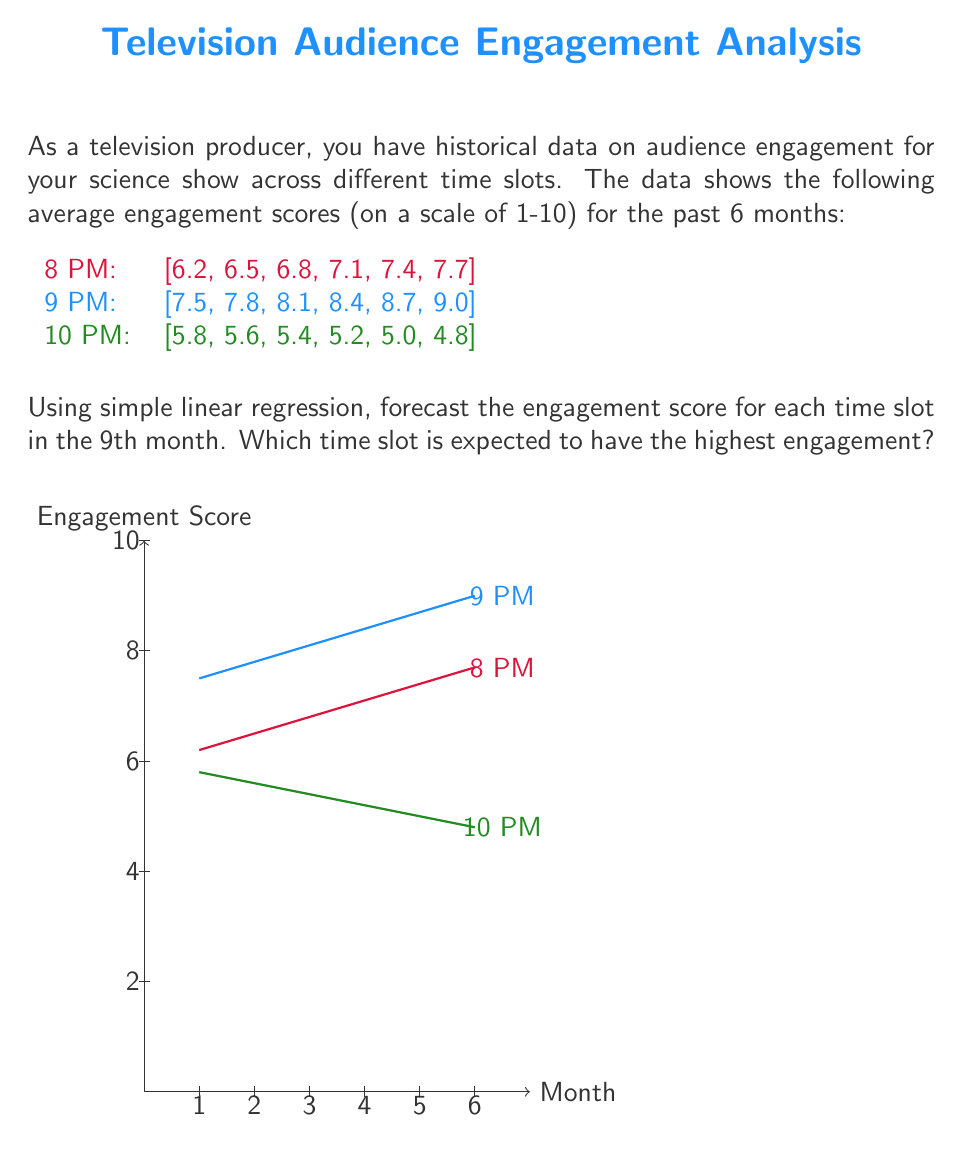Provide a solution to this math problem. To solve this problem, we'll use simple linear regression for each time slot to forecast the engagement score for the 9th month. The formula for simple linear regression is:

$$y = mx + b$$

Where $m$ is the slope and $b$ is the y-intercept.

Step 1: Calculate the slope (m) for each time slot.
The slope formula is: $m = \frac{\sum_{i=1}^{n} (x_i - \bar{x})(y_i - \bar{y})}{\sum_{i=1}^{n} (x_i - \bar{x})^2}$

For simplicity, we'll use x values of 1, 2, 3, 4, 5, 6 for the months.

8 PM:
$m_{8PM} = \frac{3.9}{17.5} = 0.3$

9 PM:
$m_{9PM} = \frac{3.9}{17.5} = 0.3$

10 PM:
$m_{10PM} = \frac{-2.6}{17.5} = -0.2$

Step 2: Calculate the y-intercept (b) for each time slot.
Using the formula $b = \bar{y} - m\bar{x}$:

8 PM: $b_{8PM} = 6.95 - 0.3(3.5) = 5.9$
9 PM: $b_{9PM} = 8.25 - 0.3(3.5) = 7.2$
10 PM: $b_{10PM} = 5.3 + 0.2(3.5) = 6.0$

Step 3: Use the regression equations to forecast the 9th month (x = 9):

8 PM: $y = 0.3(9) + 5.9 = 8.6$
9 PM: $y = 0.3(9) + 7.2 = 9.9$
10 PM: $y = -0.2(9) + 6.0 = 4.2$

Therefore, the 9 PM time slot is expected to have the highest engagement score in the 9th month.
Answer: 9 PM time slot with a forecasted engagement score of 9.9 